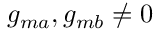Convert formula to latex. <formula><loc_0><loc_0><loc_500><loc_500>g _ { m a } , g _ { m b } \neq 0</formula> 